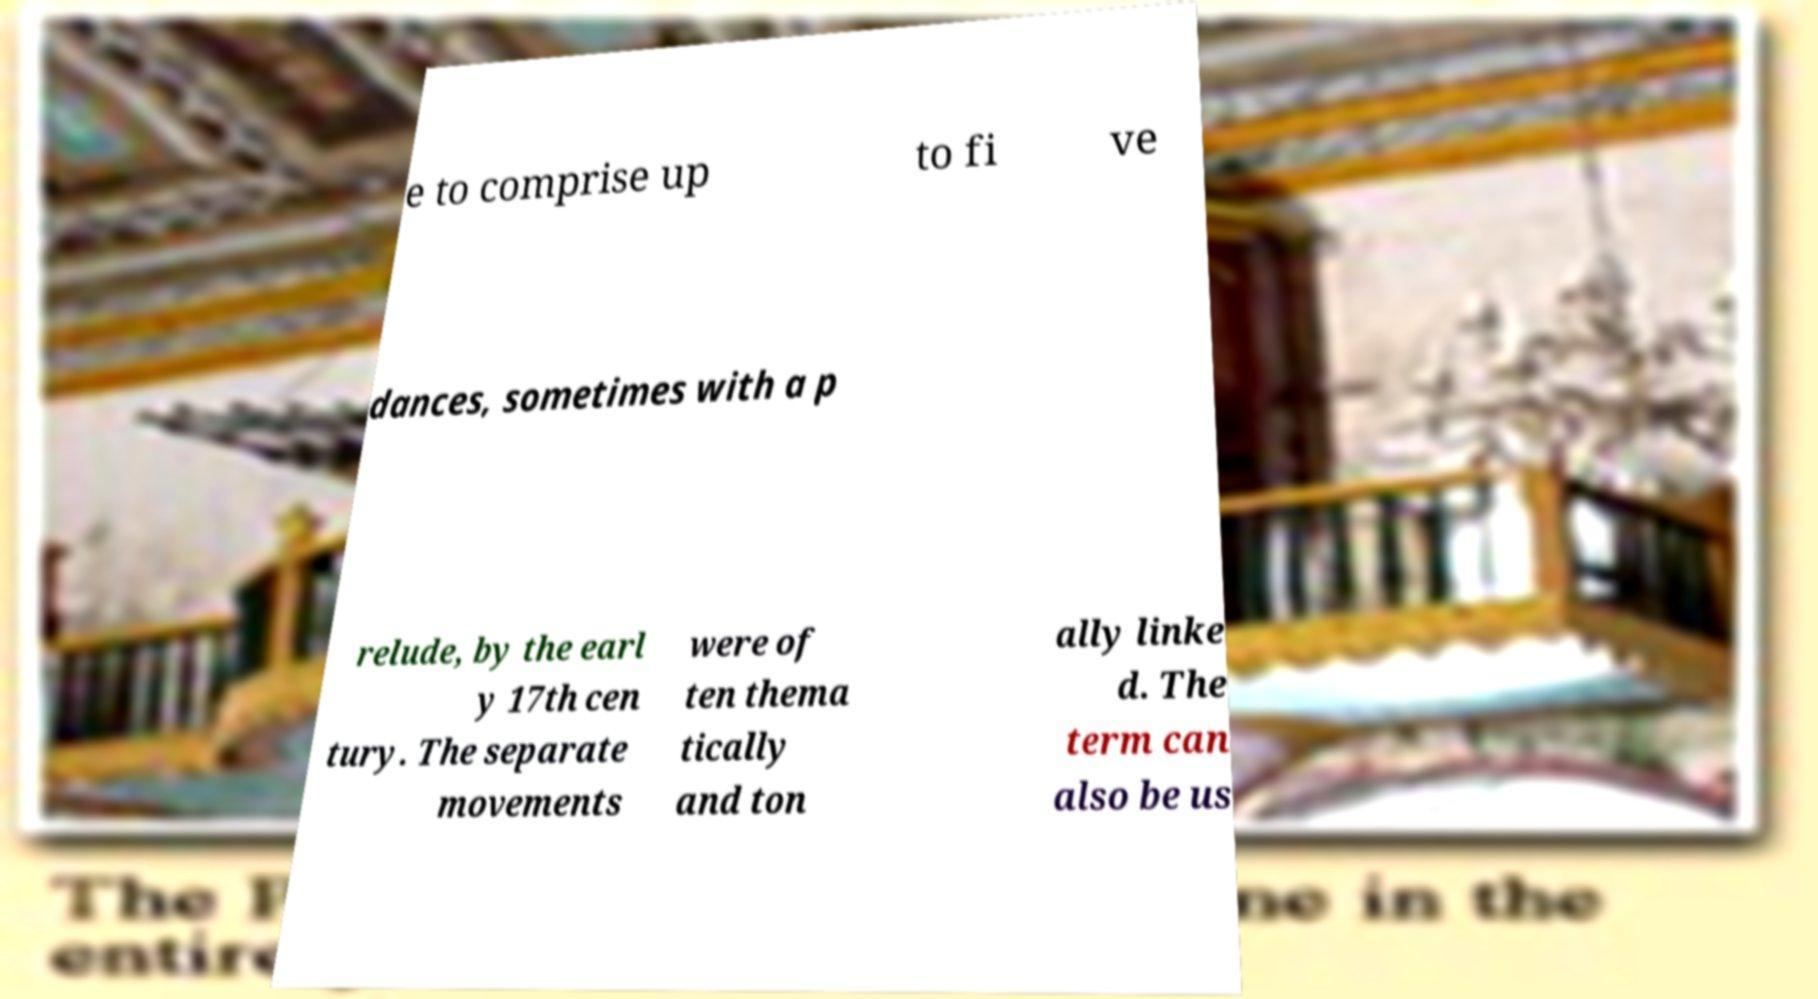For documentation purposes, I need the text within this image transcribed. Could you provide that? e to comprise up to fi ve dances, sometimes with a p relude, by the earl y 17th cen tury. The separate movements were of ten thema tically and ton ally linke d. The term can also be us 